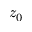<formula> <loc_0><loc_0><loc_500><loc_500>z _ { 0 }</formula> 